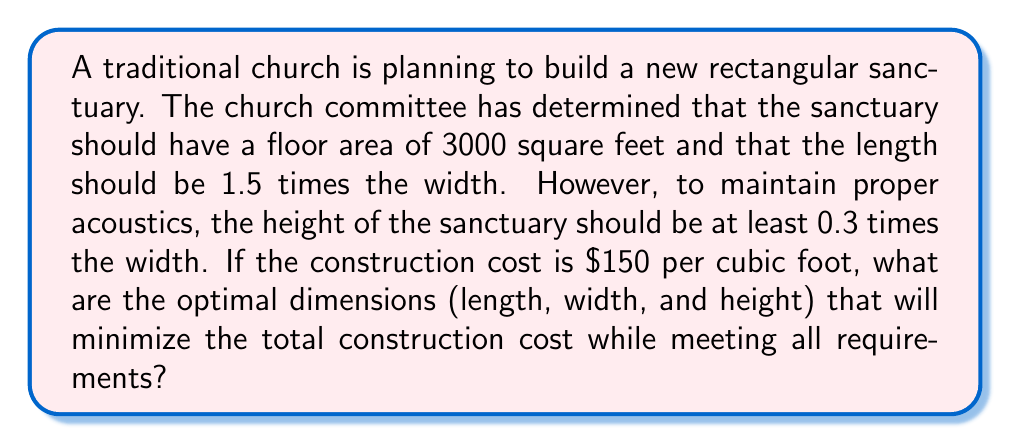What is the answer to this math problem? Let's approach this step-by-step:

1) Let $w$ be the width of the sanctuary. Then:
   - Length = $1.5w$
   - Area = $3000 \text{ sq ft} = 1.5w \cdot w = 1.5w^2$

2) From the area equation:
   $$1.5w^2 = 3000$$
   $$w^2 = 2000$$
   $$w = \sqrt{2000} \approx 44.72 \text{ ft}$$

3) The length is then:
   $$l = 1.5w = 1.5 \cdot 44.72 \approx 67.08 \text{ ft}$$

4) For the height, we need to consider the acoustic requirement:
   $$h \geq 0.3w = 0.3 \cdot 44.72 \approx 13.42 \text{ ft}$$

5) To minimize cost, we should use the minimum allowed height:
   $$h = 13.42 \text{ ft}$$

6) The volume of the sanctuary is:
   $$V = l \cdot w \cdot h = 67.08 \cdot 44.72 \cdot 13.42 \approx 40,200 \text{ cubic feet}$$

7) The total construction cost is:
   $$\text{Cost} = 150 \cdot 40,200 = \$6,030,000$$

Therefore, the optimal dimensions that minimize cost while meeting all requirements are:
- Width: 44.72 ft
- Length: 67.08 ft
- Height: 13.42 ft
Answer: The optimal dimensions are approximately:
Width: 44.72 ft
Length: 67.08 ft
Height: 13.42 ft 